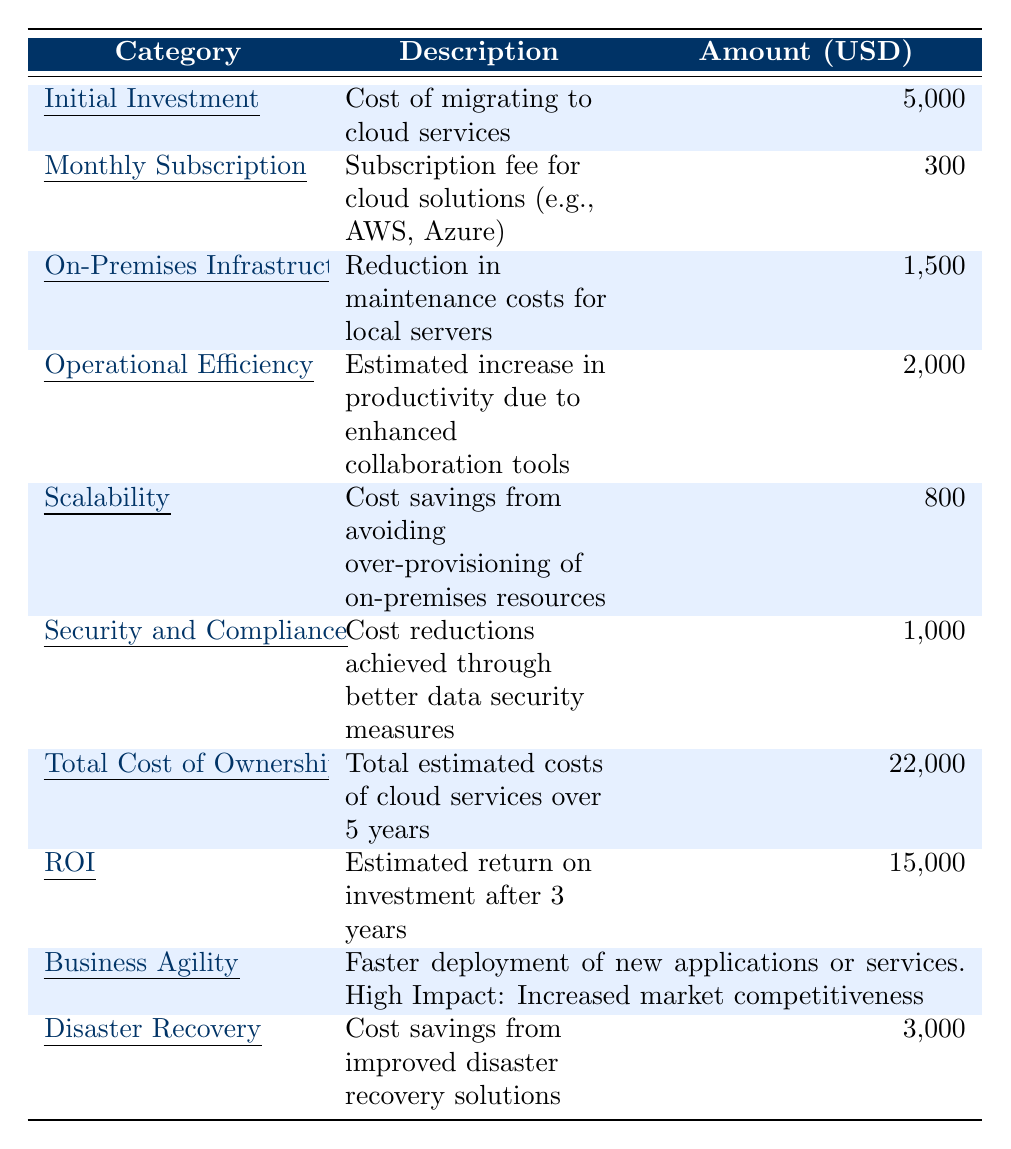What is the total amount for the initial investment? The table lists the cost of migrating to cloud services under the initial investment category, which is 5,000 USD.
Answer: 5,000 USD What is the estimated return on investment after 3 years? The table provides the estimated return on investment, which is labeled as ROI, and this value is 15,000 USD.
Answer: 15,000 USD What is the total cost of ownership over 5 years? The table specifies the total estimated costs of cloud services over 5 years, which is indicated as 22,000 USD.
Answer: 22,000 USD How much is saved from operational efficiency? The increase in productivity from enhanced collaboration tools, listed under operational efficiency, amounts to 2,000 USD.
Answer: 2,000 USD What are the total savings from on-premises infrastructure and disaster recovery combined? Adding the on-premises infrastructure savings of 1,500 USD and disaster recovery savings of 3,000 USD gives (1,500 + 3,000) = 4,500 USD as total savings.
Answer: 4,500 USD Is the monthly subscription cost higher than the security and compliance savings? The monthly subscription cost is 300 USD while the savings from security and compliance are 1,000 USD, which means the statement is false since 300 < 1,000.
Answer: No What is the total estimated benefit from increased business agility? Business agility is noted to have a high impact in terms of increased market competitiveness, but since there is no specific monetary value associated with it in the table, it cannot be quantified as a dollar amount.
Answer: Not quantifiable How much more does the total cost of ownership exceed the initial investment? Subtracting the initial investment of 5,000 USD from the total cost of ownership of 22,000 USD gives (22,000 - 5,000) = 17,000 USD, indicating how much more TCO exceeds the initial investment.
Answer: 17,000 USD What is the overall monthly cost of cloud services over a year? The monthly subscription fee is 300 USD; therefore, multiplying this by 12 months gives a total yearly cost of (300 x 12) = 3,600 USD.
Answer: 3,600 USD Does the cost of the initial investment contribute more to the TCO than the annual subscription cost over 5 years? The initial investment is 5,000 USD, and over 5 years the total figured from monthly subscriptions would be (300 x 12 x 5) = 18,000 USD. Since 5,000 < 18,000, the statement is false.
Answer: No 